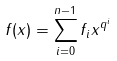<formula> <loc_0><loc_0><loc_500><loc_500>f ( x ) = \sum _ { i = 0 } ^ { n - 1 } f _ { i } x ^ { q ^ { i } }</formula> 